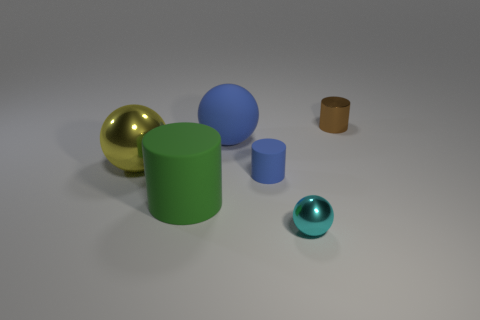Are there an equal number of tiny brown metallic cylinders that are in front of the tiny cyan shiny thing and shiny balls?
Make the answer very short. No. Is there a matte ball that has the same color as the tiny shiny cylinder?
Ensure brevity in your answer.  No. Is the size of the yellow shiny object the same as the blue rubber cylinder?
Your answer should be very brief. No. There is a shiny thing left of the small metallic thing in front of the tiny brown cylinder; how big is it?
Make the answer very short. Large. What is the size of the metallic object that is both behind the small cyan shiny ball and to the left of the small metallic cylinder?
Your answer should be compact. Large. What number of other objects are the same size as the cyan object?
Offer a terse response. 2. How many rubber objects are either balls or small yellow objects?
Keep it short and to the point. 1. The object that is the same color as the small rubber cylinder is what size?
Ensure brevity in your answer.  Large. There is a tiny cylinder that is left of the small brown cylinder on the right side of the blue ball; what is its material?
Your answer should be very brief. Rubber. What number of things are objects or shiny balls that are behind the cyan ball?
Offer a terse response. 6. 